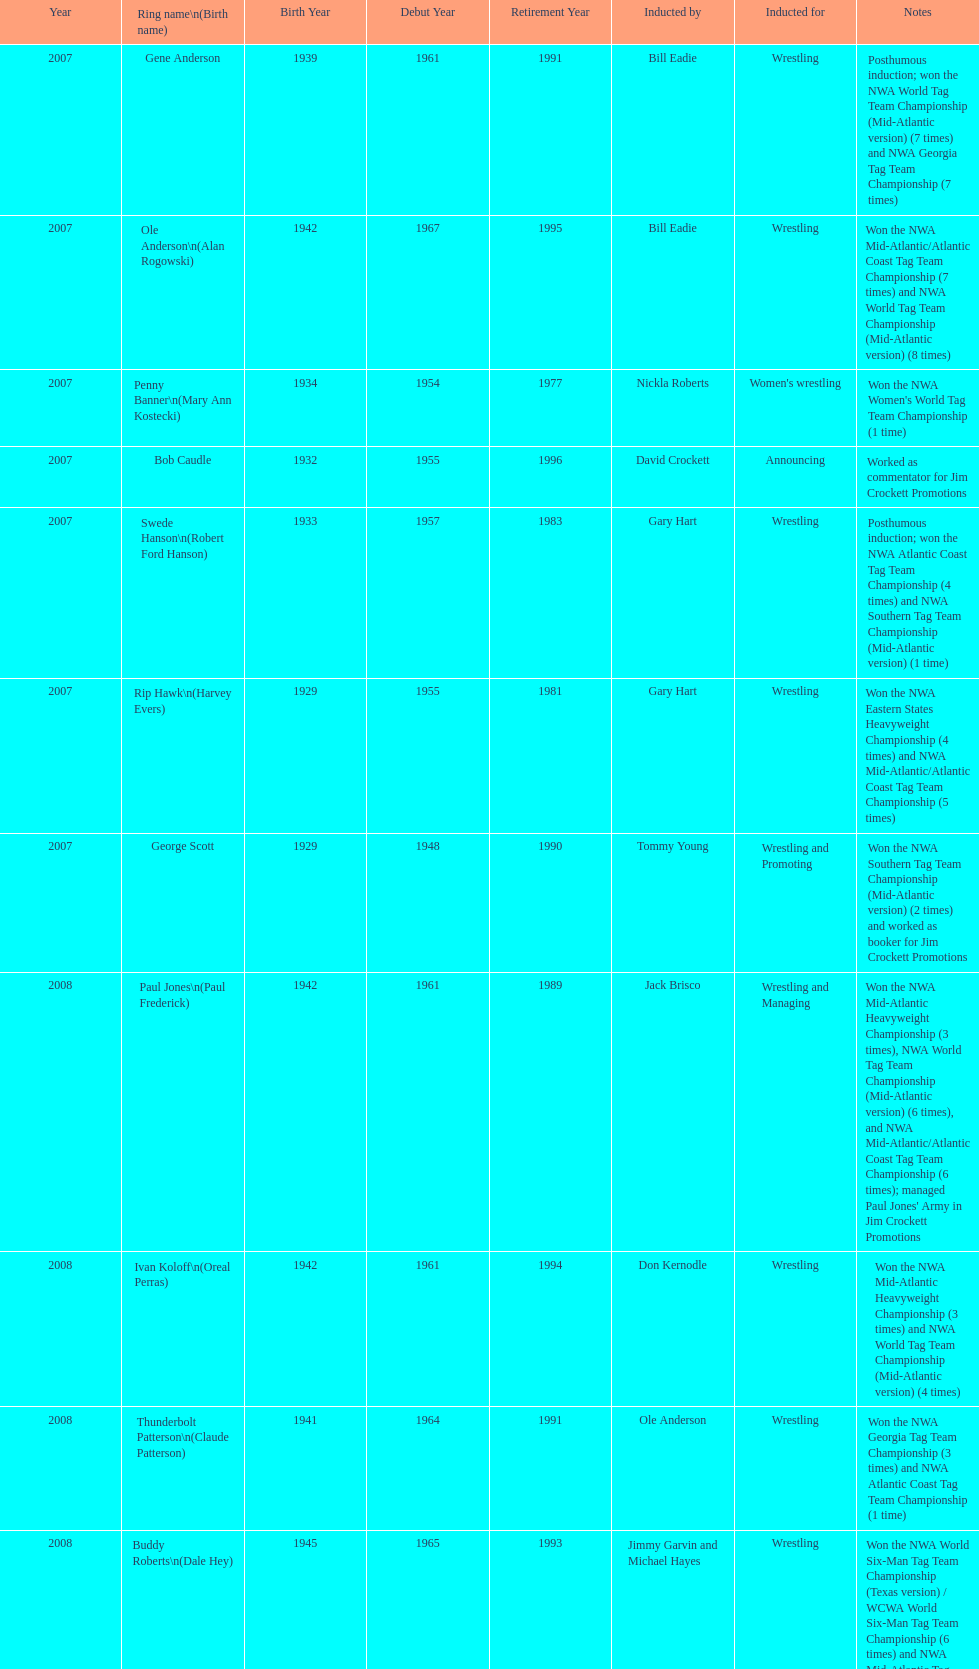Would you mind parsing the complete table? {'header': ['Year', 'Ring name\\n(Birth name)', 'Birth Year', 'Debut Year', 'Retirement Year', 'Inducted by', 'Inducted for', 'Notes'], 'rows': [['2007', 'Gene Anderson', '1939', '1961', '1991', 'Bill Eadie', 'Wrestling', 'Posthumous induction; won the NWA World Tag Team Championship (Mid-Atlantic version) (7 times) and NWA Georgia Tag Team Championship (7 times)'], ['2007', 'Ole Anderson\\n(Alan Rogowski)', '1942', '1967', '1995', 'Bill Eadie', 'Wrestling', 'Won the NWA Mid-Atlantic/Atlantic Coast Tag Team Championship (7 times) and NWA World Tag Team Championship (Mid-Atlantic version) (8 times)'], ['2007', 'Penny Banner\\n(Mary Ann Kostecki)', '1934', '1954', '1977', 'Nickla Roberts', "Women's wrestling", "Won the NWA Women's World Tag Team Championship (1 time)"], ['2007', 'Bob Caudle', '1932', '1955', '1996', 'David Crockett', 'Announcing', 'Worked as commentator for Jim Crockett Promotions'], ['2007', 'Swede Hanson\\n(Robert Ford Hanson)', '1933', '1957', '1983', 'Gary Hart', 'Wrestling', 'Posthumous induction; won the NWA Atlantic Coast Tag Team Championship (4 times) and NWA Southern Tag Team Championship (Mid-Atlantic version) (1 time)'], ['2007', 'Rip Hawk\\n(Harvey Evers)', '1929', '1955', '1981', 'Gary Hart', 'Wrestling', 'Won the NWA Eastern States Heavyweight Championship (4 times) and NWA Mid-Atlantic/Atlantic Coast Tag Team Championship (5 times)'], ['2007', 'George Scott', '1929', '1948', '1990', 'Tommy Young', 'Wrestling and Promoting', 'Won the NWA Southern Tag Team Championship (Mid-Atlantic version) (2 times) and worked as booker for Jim Crockett Promotions'], ['2008', 'Paul Jones\\n(Paul Frederick)', '1942', '1961', '1989', 'Jack Brisco', 'Wrestling and Managing', "Won the NWA Mid-Atlantic Heavyweight Championship (3 times), NWA World Tag Team Championship (Mid-Atlantic version) (6 times), and NWA Mid-Atlantic/Atlantic Coast Tag Team Championship (6 times); managed Paul Jones' Army in Jim Crockett Promotions"], ['2008', 'Ivan Koloff\\n(Oreal Perras)', '1942', '1961', '1994', 'Don Kernodle', 'Wrestling', 'Won the NWA Mid-Atlantic Heavyweight Championship (3 times) and NWA World Tag Team Championship (Mid-Atlantic version) (4 times)'], ['2008', 'Thunderbolt Patterson\\n(Claude Patterson)', '1941', '1964', '1991', 'Ole Anderson', 'Wrestling', 'Won the NWA Georgia Tag Team Championship (3 times) and NWA Atlantic Coast Tag Team Championship (1 time)'], ['2008', 'Buddy Roberts\\n(Dale Hey)', '1945', '1965', '1993', 'Jimmy Garvin and Michael Hayes', 'Wrestling', 'Won the NWA World Six-Man Tag Team Championship (Texas version) / WCWA World Six-Man Tag Team Championship (6 times) and NWA Mid-Atlantic Tag Team Championship (1 time)'], ['2008', 'Sandy Scott\\n(Angus Mackay Scott)', '1934', '1954', '1984', 'Bob Caudle', 'Wrestling and Promoting', 'Worked as an executive for Jim Crockett Promotions and won the NWA World Tag Team Championship (Central States version) (1 time) and NWA Southern Tag Team Championship (Mid-Atlantic version) (3 times)'], ['2008', 'Grizzly Smith\\n(Aurelian Smith)', '1932', '1958', '1985', 'Magnum T.A.', 'Wrestling', 'Won the NWA United States Tag Team Championship (Tri-State version) (2 times) and NWA Texas Heavyweight Championship (1 time)'], ['2008', 'Johnny Weaver\\n(Kenneth Eugene Weaver)', '1935', '1957', '1988', 'Rip Hawk', 'Wrestling', 'Posthumous induction; won the NWA Atlantic Coast/Mid-Atlantic Tag Team Championship (8 times) and NWA Southern Tag Team Championship (Mid-Atlantic version) (6 times)'], ['2009', 'Don Fargo\\n(Don Kalt)', '1930', '1952', '1986', 'Jerry Jarrett & Steve Keirn', 'Wrestling', 'Won the NWA Southern Tag Team Championship (Mid-America version) (2 times) and NWA World Tag Team Championship (Mid-America version) (6 times)'], ['2009', 'Jackie Fargo\\n(Henry Faggart)', '1930', '1952', '1988', 'Jerry Jarrett & Steve Keirn', 'Wrestling', 'Won the NWA World Tag Team Championship (Mid-America version) (10 times) and NWA Southern Tag Team Championship (Mid-America version) (22 times)'], ['2009', 'Sonny Fargo\\n(Jack Lewis Faggart)', '1931', '1954', '1986', 'Jerry Jarrett & Steve Keirn', 'Wrestling', 'Posthumous induction; won the NWA Southern Tag Team Championship (Mid-America version) (3 times)'], ['2009', 'Gary Hart\\n(Gary Williams)', '1942', '1960', '2008', 'Sir Oliver Humperdink', 'Managing and Promoting', 'Posthumous induction; worked as a booker in World Class Championship Wrestling and managed several wrestlers in Mid-Atlantic Championship Wrestling'], ['2009', 'Wahoo McDaniel\\n(Edward McDaniel)', '1938', '1961', '1988', 'Tully Blanchard', 'Wrestling', 'Posthumous induction; won the NWA Mid-Atlantic Heavyweight Championship (6 times) and NWA World Tag Team Championship (Mid-Atlantic version) (4 times)'], ['2009', 'Blackjack Mulligan\\n(Robert Windham)', '1942', '1967', '1989', 'Ric Flair', 'Wrestling', 'Won the NWA Texas Heavyweight Championship (1 time) and NWA World Tag Team Championship (Mid-Atlantic version) (1 time)'], ['2009', 'Nelson Royal', '1935', '1963', '1997', 'Brad Anderson, Tommy Angel & David Isley', 'Wrestling', 'Won the NWA Atlantic Coast Tag Team Championship (2 times)'], ['2009', 'Lance Russell', '1926', '1959', '2001', 'Dave Brown', 'Announcing', 'Worked as commentator for wrestling events in the Memphis area']]} What number of members were inducted before 2009? 14. 